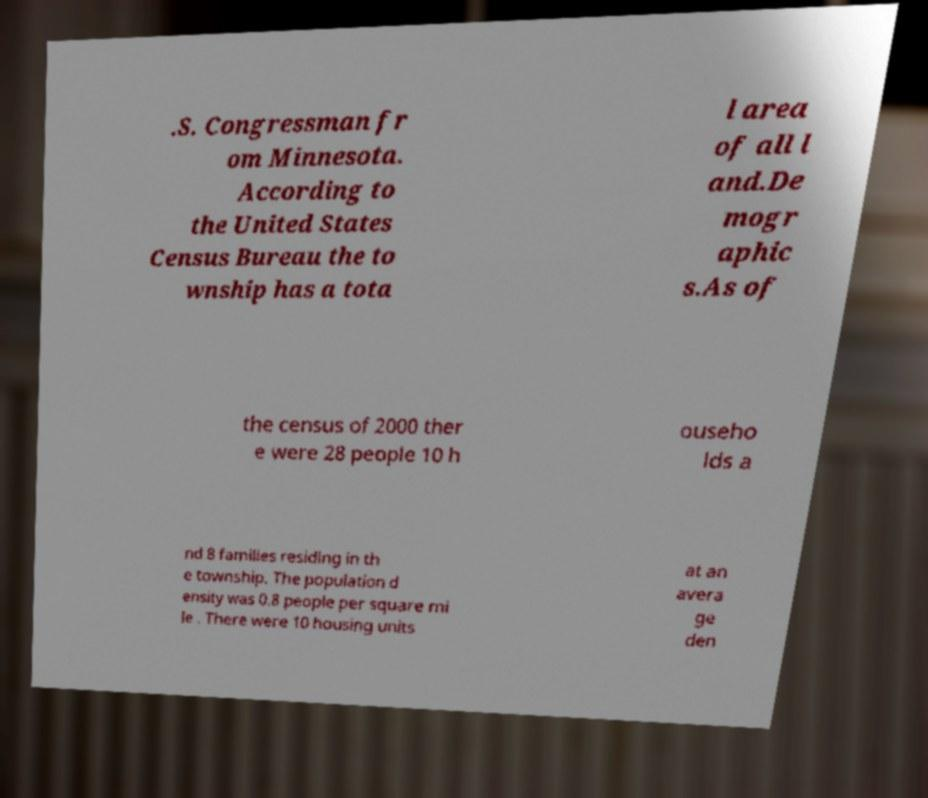Can you read and provide the text displayed in the image?This photo seems to have some interesting text. Can you extract and type it out for me? .S. Congressman fr om Minnesota. According to the United States Census Bureau the to wnship has a tota l area of all l and.De mogr aphic s.As of the census of 2000 ther e were 28 people 10 h ouseho lds a nd 8 families residing in th e township. The population d ensity was 0.8 people per square mi le . There were 10 housing units at an avera ge den 